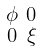<formula> <loc_0><loc_0><loc_500><loc_500>\begin{smallmatrix} \phi & 0 \\ 0 & \xi \end{smallmatrix}</formula> 